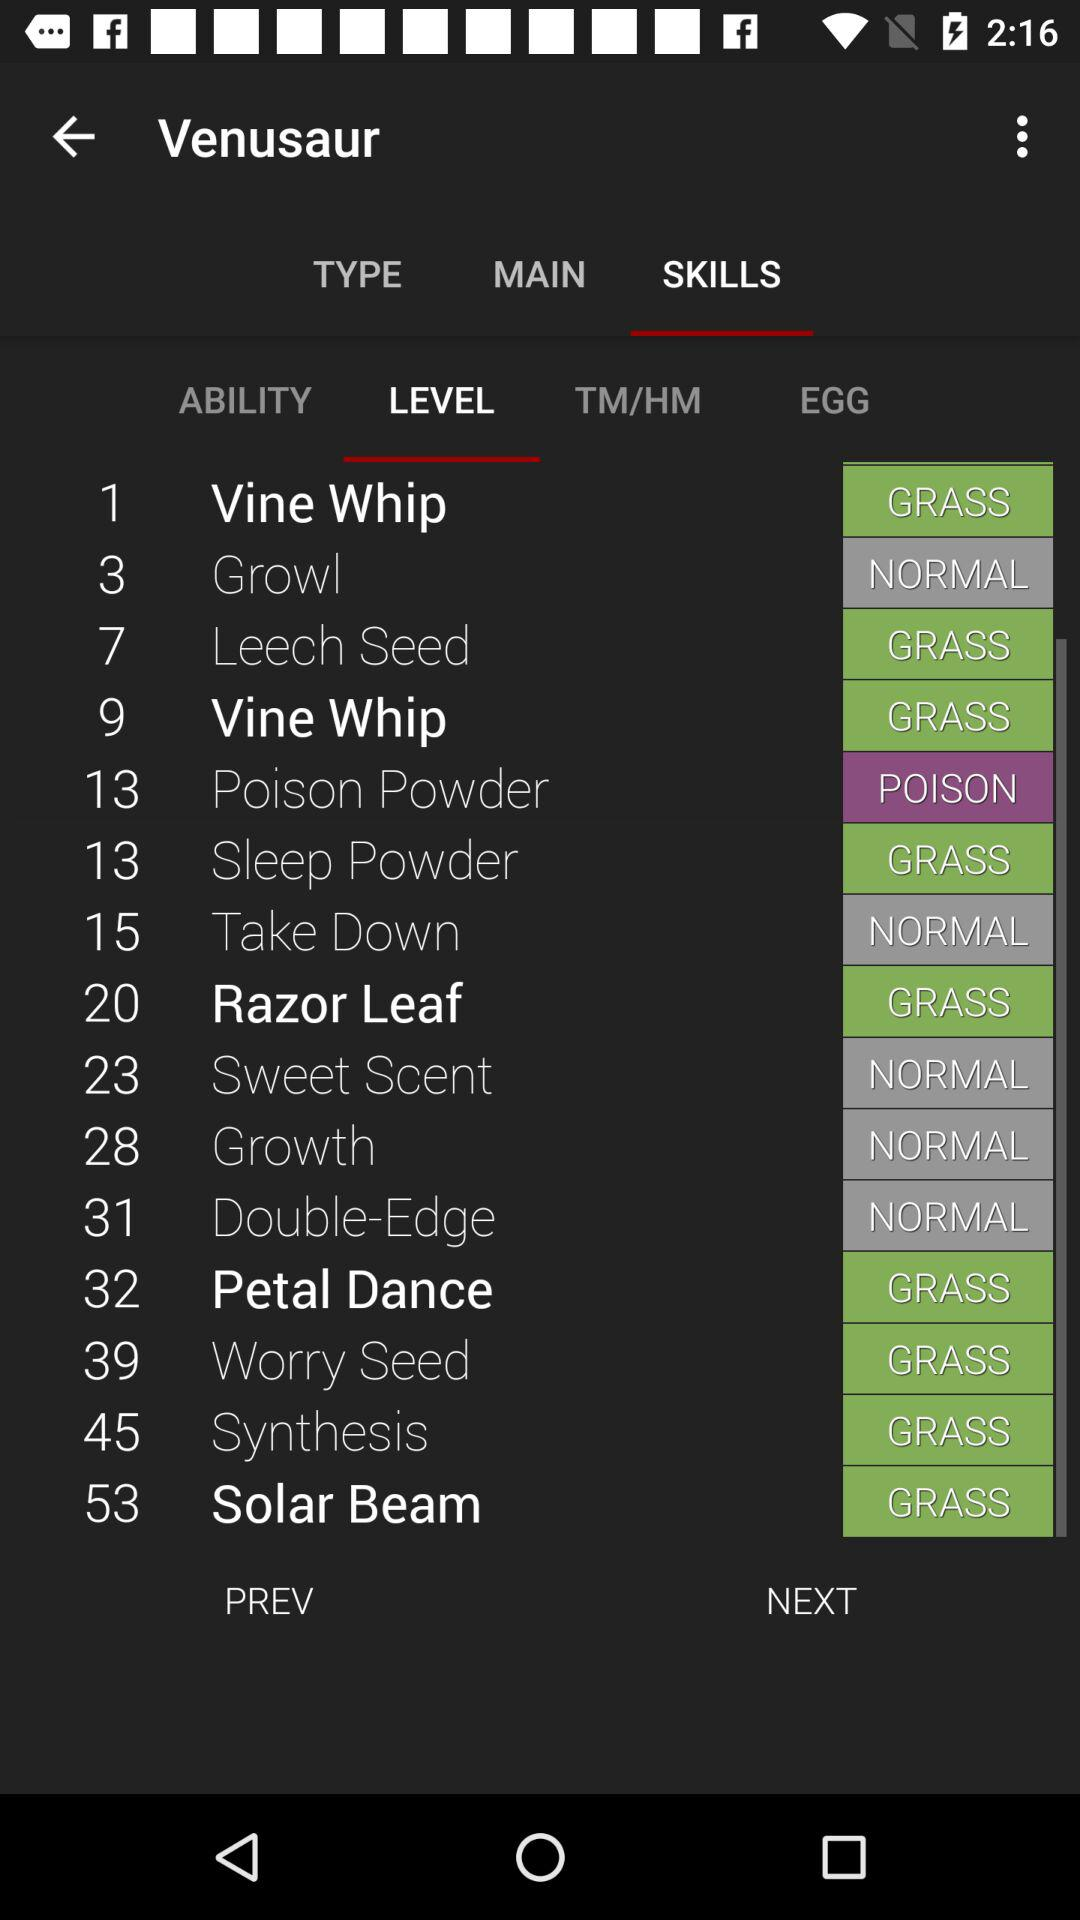What is the level of "Growl"? The level of "Growl" is 3. 